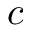Convert formula to latex. <formula><loc_0><loc_0><loc_500><loc_500>c</formula> 